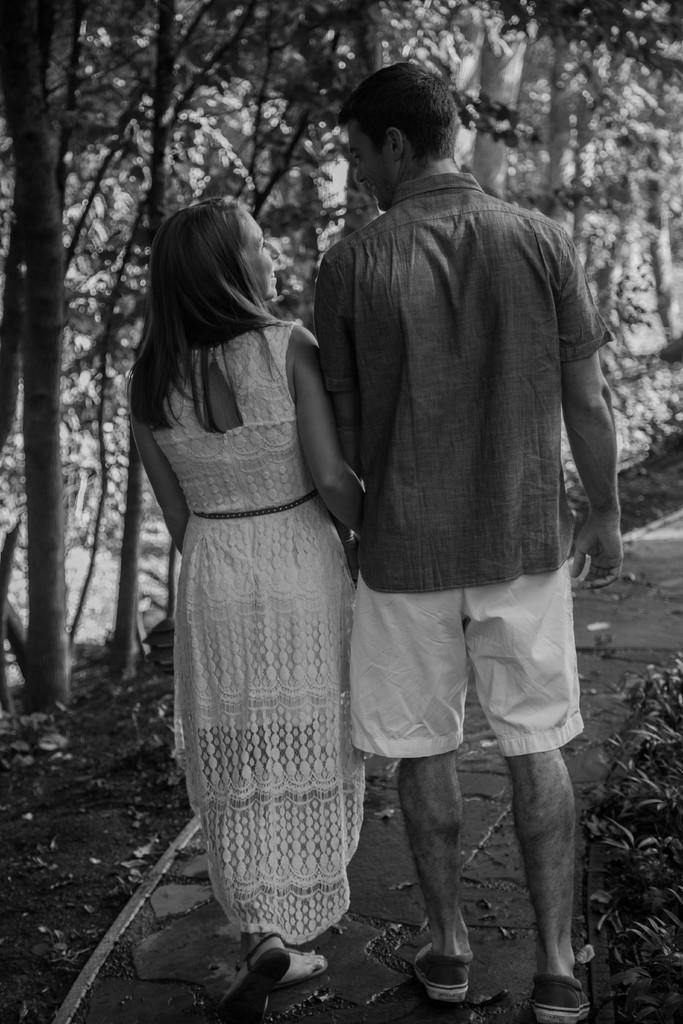How would you summarize this image in a sentence or two? This is a black and white image. Here I can see a man and a woman are walking. In the background there are many trees. 